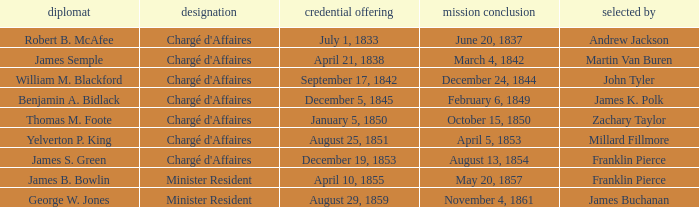Which Title has an Appointed by of Millard Fillmore? Chargé d'Affaires. 